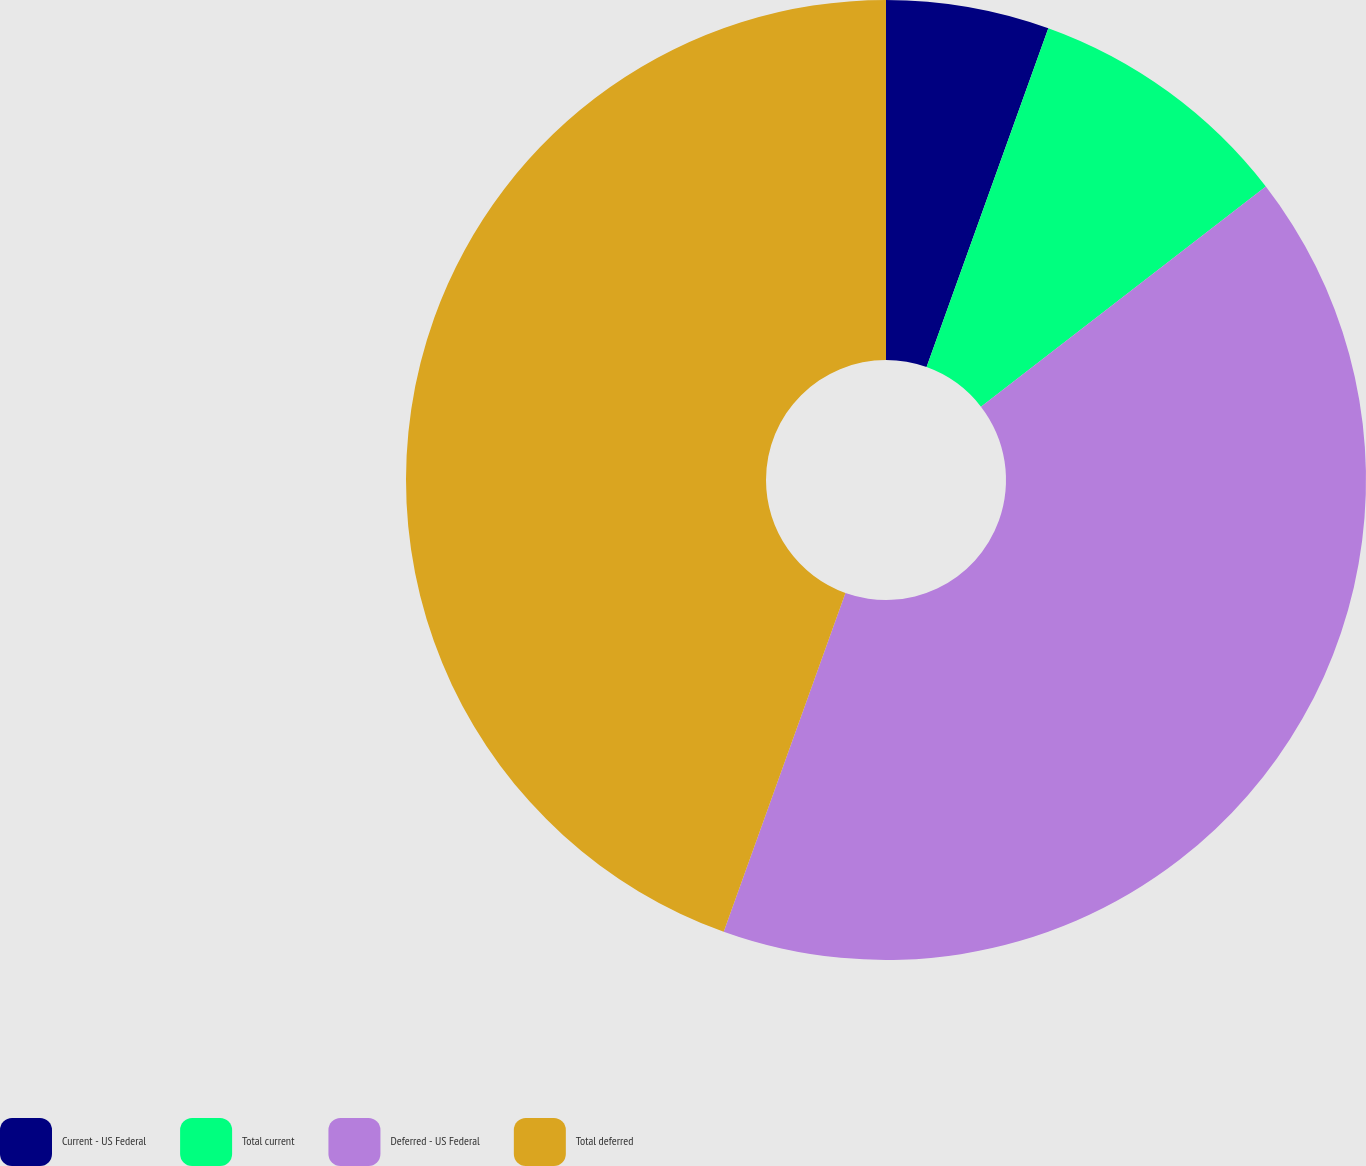Convert chart. <chart><loc_0><loc_0><loc_500><loc_500><pie_chart><fcel>Current - US Federal<fcel>Total current<fcel>Deferred - US Federal<fcel>Total deferred<nl><fcel>5.49%<fcel>9.04%<fcel>40.96%<fcel>44.51%<nl></chart> 